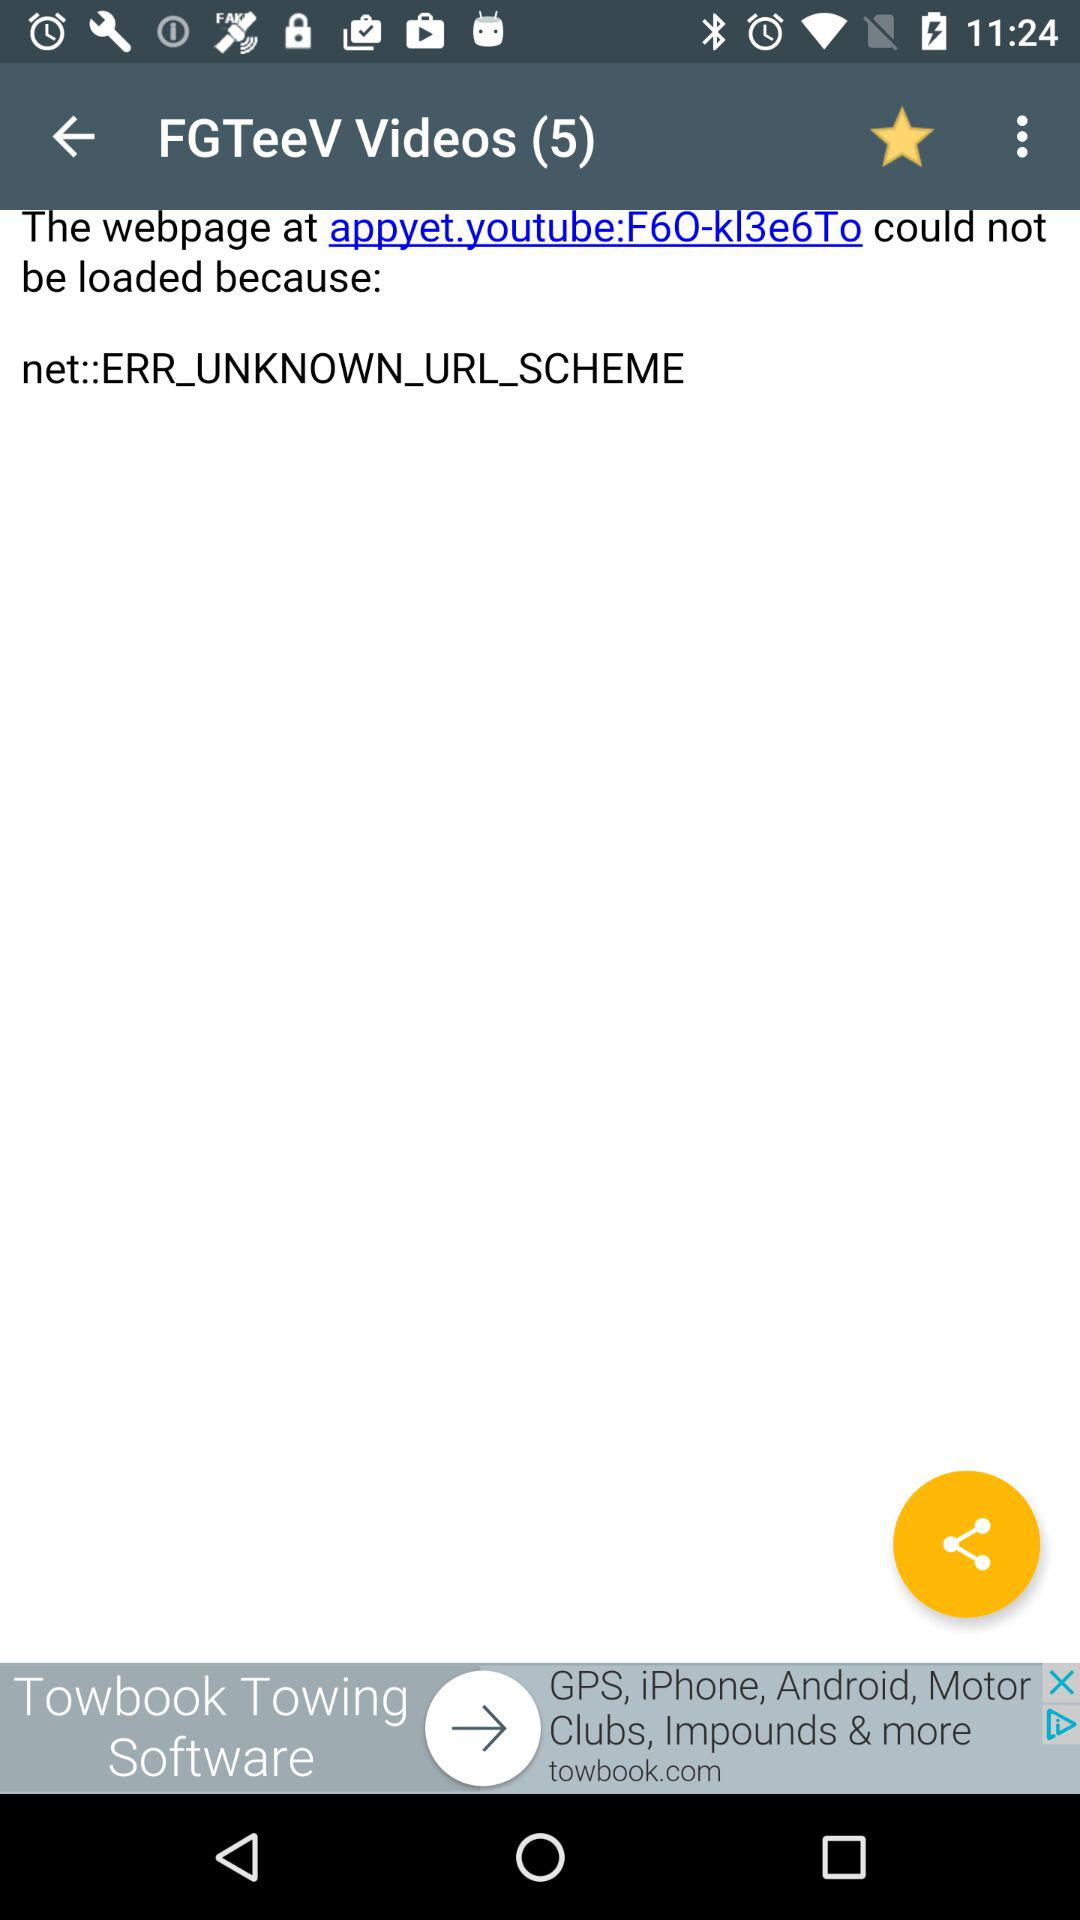What is the number of videos? The number of videos is 5. 